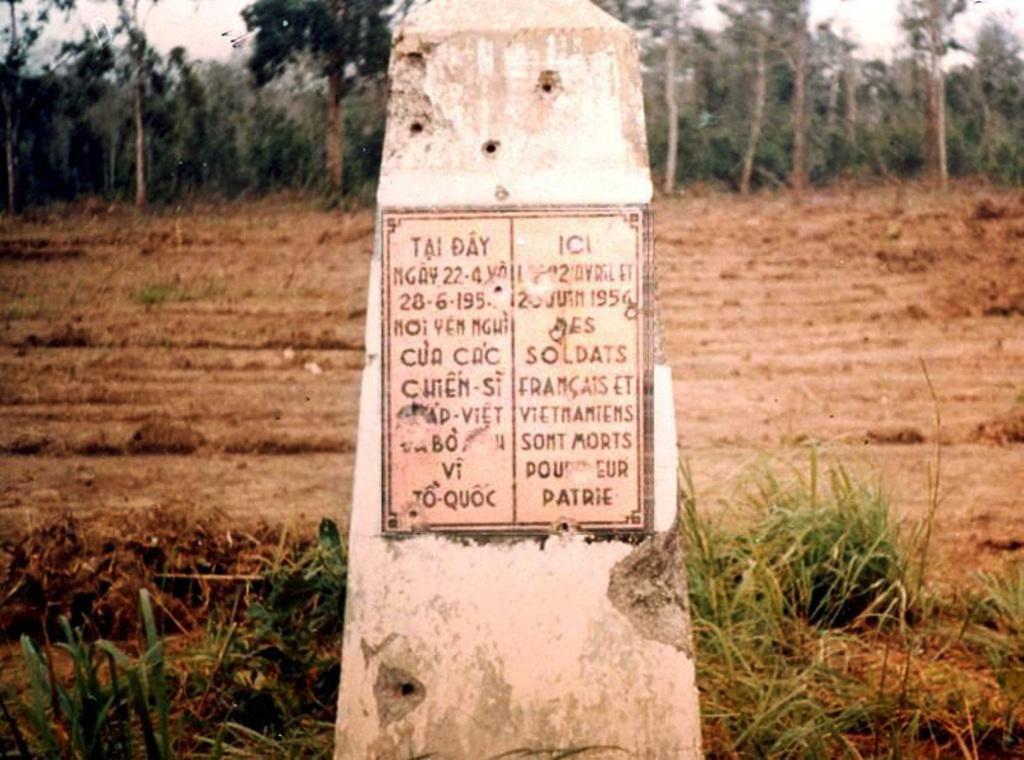How would you summarize this image in a sentence or two? This image consists of a memorial stone. At the bottom, there is a land. In the background, there are trees. 